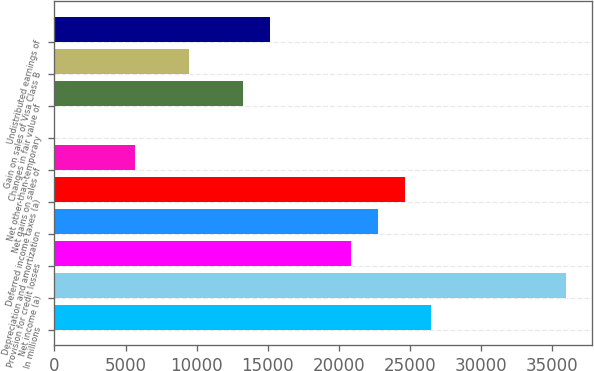<chart> <loc_0><loc_0><loc_500><loc_500><bar_chart><fcel>In millions<fcel>Net income (a)<fcel>Provision for credit losses<fcel>Depreciation and amortization<fcel>Deferred income taxes (a)<fcel>Net gains on sales of<fcel>Net other-than-temporary<fcel>Changes in fair value of<fcel>Gain on sales of Visa Class B<fcel>Undistributed earnings of<nl><fcel>26502.6<fcel>35962.1<fcel>20826.9<fcel>22718.8<fcel>24610.7<fcel>5691.7<fcel>16<fcel>13259.3<fcel>9475.5<fcel>15151.2<nl></chart> 